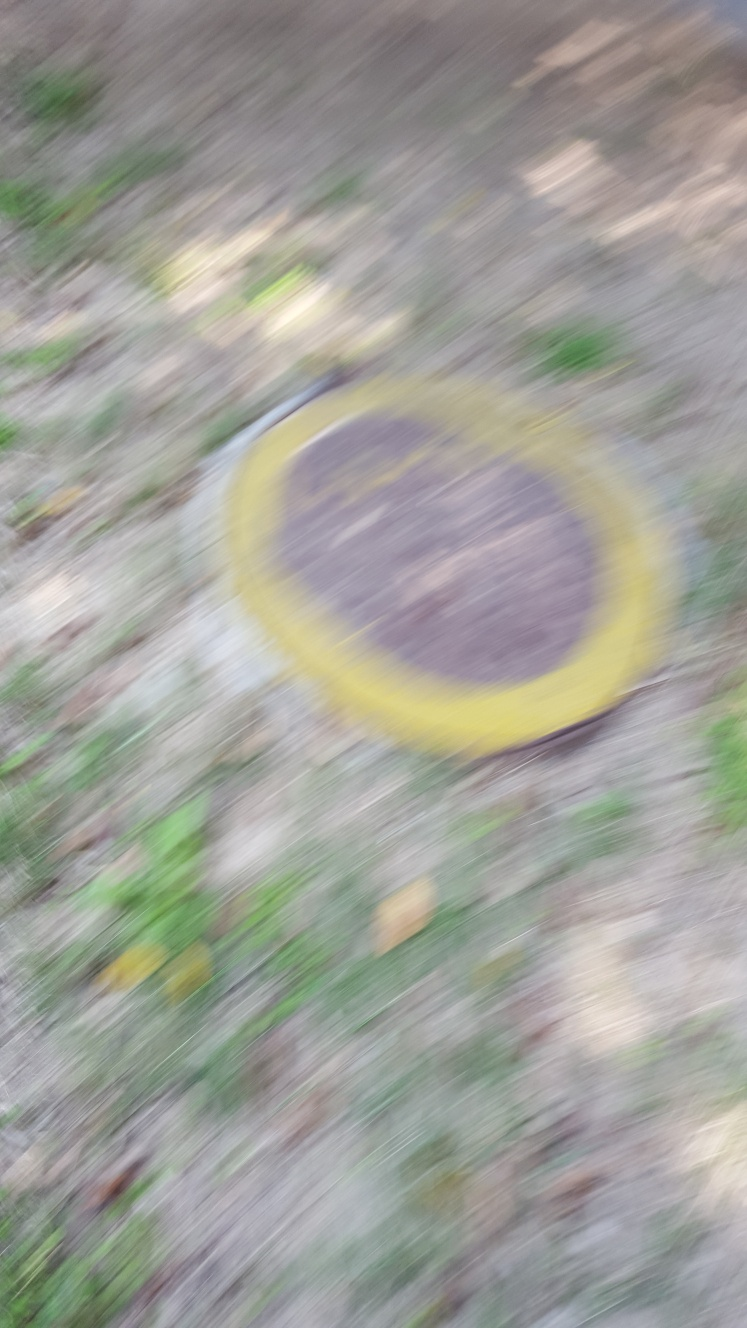Could you guess why this photo might have been taken even though it's blurry? The photographer might have captured this photo inadvertently while in motion, or it could be an artistic attempt to convey a sense of speed or motion, focusing on the color contrast between the yellow object and the natural environment rather than on sharpness. 